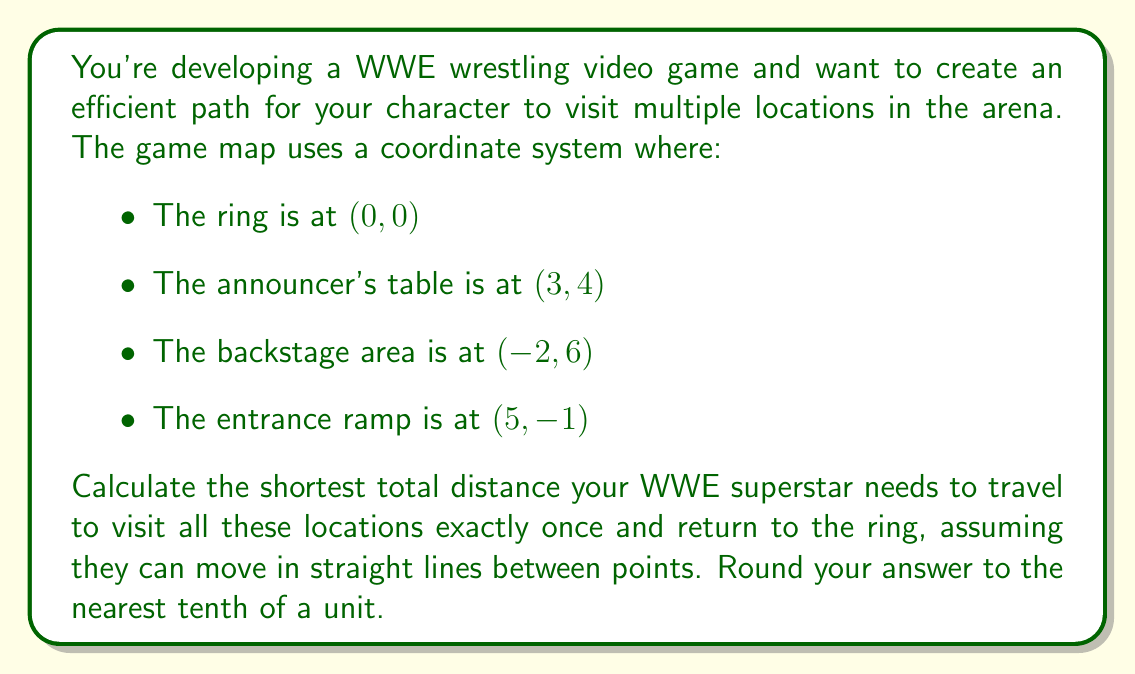Provide a solution to this math problem. To solve this problem, we need to calculate the distances between all pairs of points and find the shortest path that visits all locations once before returning to the starting point. This is known as the Traveling Salesman Problem.

Step 1: Calculate distances between all pairs of points using the distance formula:
$d = \sqrt{(x_2-x_1)^2 + (y_2-y_1)^2}$

Ring to Announcer's Table: 
$d_{RA} = \sqrt{(3-0)^2 + (4-0)^2} = 5$

Ring to Backstage:
$d_{RB} = \sqrt{(-2-0)^2 + (6-0)^2} = \sqrt{40} \approx 6.32$

Ring to Entrance Ramp:
$d_{RE} = \sqrt{(5-0)^2 + (-1-0)^2} = \sqrt{26} \approx 5.10$

Announcer's Table to Backstage:
$d_{AB} = \sqrt{(-2-3)^2 + (6-4)^2} = 5.39$

Announcer's Table to Entrance Ramp:
$d_{AE} = \sqrt{(5-3)^2 + (-1-4)^2} = \sqrt{29} \approx 5.39$

Backstage to Entrance Ramp:
$d_{BE} = \sqrt{(5-(-2))^2 + (-1-6)^2} = \sqrt{106} \approx 10.30$

Step 2: Find the shortest path

For 4 locations, there are 3! = 6 possible paths. We need to calculate the total distance for each path and find the shortest one:

1. Ring → Announcer's Table → Backstage → Entrance Ramp → Ring
   $5 + 5.39 + 10.30 + 5.10 = 25.79$

2. Ring → Announcer's Table → Entrance Ramp → Backstage → Ring
   $5 + 5.39 + 10.30 + 6.32 = 27.01$

3. Ring → Backstage → Announcer's Table → Entrance Ramp → Ring
   $6.32 + 5.39 + 5.39 + 5.10 = 22.20$

4. Ring → Backstage → Entrance Ramp → Announcer's Table → Ring
   $6.32 + 10.30 + 5.39 + 5 = 27.01$

5. Ring → Entrance Ramp → Announcer's Table → Backstage → Ring
   $5.10 + 5.39 + 5.39 + 6.32 = 22.20$

6. Ring → Entrance Ramp → Backstage → Announcer's Table → Ring
   $5.10 + 10.30 + 5.39 + 5 = 25.79$

The shortest path is either 3 or 5, both with a total distance of 22.20 units.

Step 3: Round to the nearest tenth

22.20 rounded to the nearest tenth is 22.2 units.
Answer: The shortest total distance the WWE superstar needs to travel to visit all locations once and return to the ring is 22.2 units. 